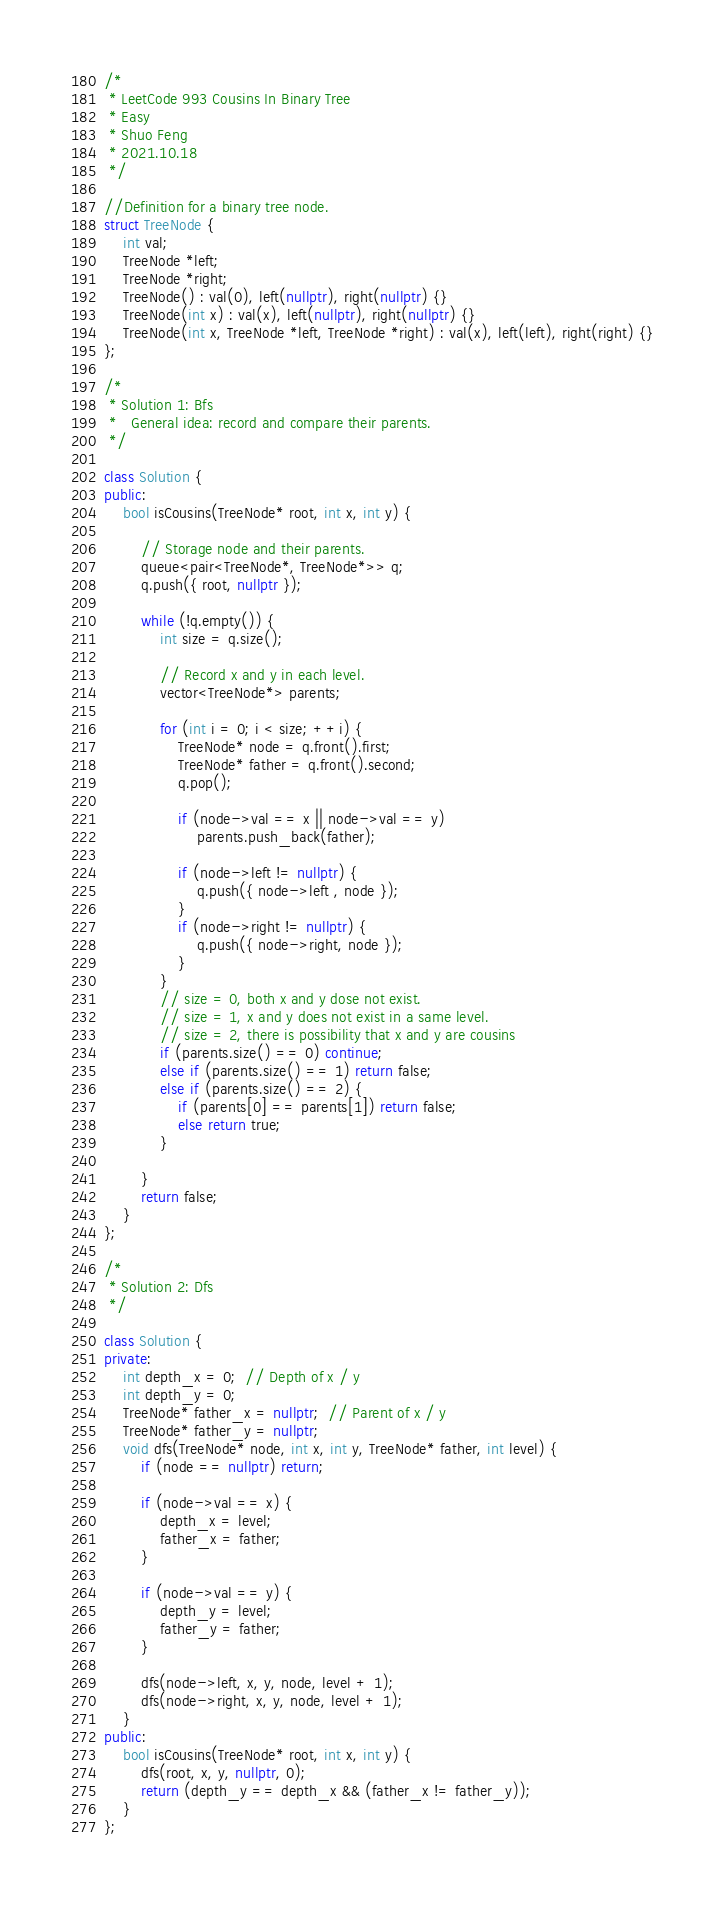<code> <loc_0><loc_0><loc_500><loc_500><_C++_>/*
 * LeetCode 993 Cousins In Binary Tree
 * Easy
 * Shuo Feng
 * 2021.10.18
 */

//Definition for a binary tree node.
struct TreeNode {
    int val;
    TreeNode *left;
    TreeNode *right;
    TreeNode() : val(0), left(nullptr), right(nullptr) {}
    TreeNode(int x) : val(x), left(nullptr), right(nullptr) {}
    TreeNode(int x, TreeNode *left, TreeNode *right) : val(x), left(left), right(right) {}
};

/*
 * Solution 1: Bfs
 *   General idea: record and compare their parents.
 */

class Solution {
public:
    bool isCousins(TreeNode* root, int x, int y) {
      
        // Storage node and their parents.
        queue<pair<TreeNode*, TreeNode*>> q;
        q.push({ root, nullptr });

        while (!q.empty()) {
            int size = q.size();
          
            // Record x and y in each level.
            vector<TreeNode*> parents;

            for (int i = 0; i < size; ++i) {
                TreeNode* node = q.front().first;
                TreeNode* father = q.front().second;
                q.pop();

                if (node->val == x || node->val == y)
                    parents.push_back(father);

                if (node->left != nullptr) {
                    q.push({ node->left , node });
                }
                if (node->right != nullptr) {
                    q.push({ node->right, node });
                }
            }
            // size = 0, both x and y dose not exist.
            // size = 1, x and y does not exist in a same level.
            // size = 2, there is possibility that x and y are cousins
            if (parents.size() == 0) continue;
            else if (parents.size() == 1) return false;
            else if (parents.size() == 2) {
                if (parents[0] == parents[1]) return false;
                else return true;
            }

        }
        return false;
    }
};

/*
 * Solution 2: Dfs
 */

class Solution {
private:
    int depth_x = 0;  // Depth of x / y
    int depth_y = 0;
    TreeNode* father_x = nullptr;  // Parent of x / y
    TreeNode* father_y = nullptr;
    void dfs(TreeNode* node, int x, int y, TreeNode* father, int level) {
        if (node == nullptr) return;

        if (node->val == x) {
            depth_x = level;
            father_x = father;
        }

        if (node->val == y) {
            depth_y = level;
            father_y = father;
        }

        dfs(node->left, x, y, node, level + 1);
        dfs(node->right, x, y, node, level + 1);
    }
public:
    bool isCousins(TreeNode* root, int x, int y) {
        dfs(root, x, y, nullptr, 0);
        return (depth_y == depth_x && (father_x != father_y));
    }
};
</code> 